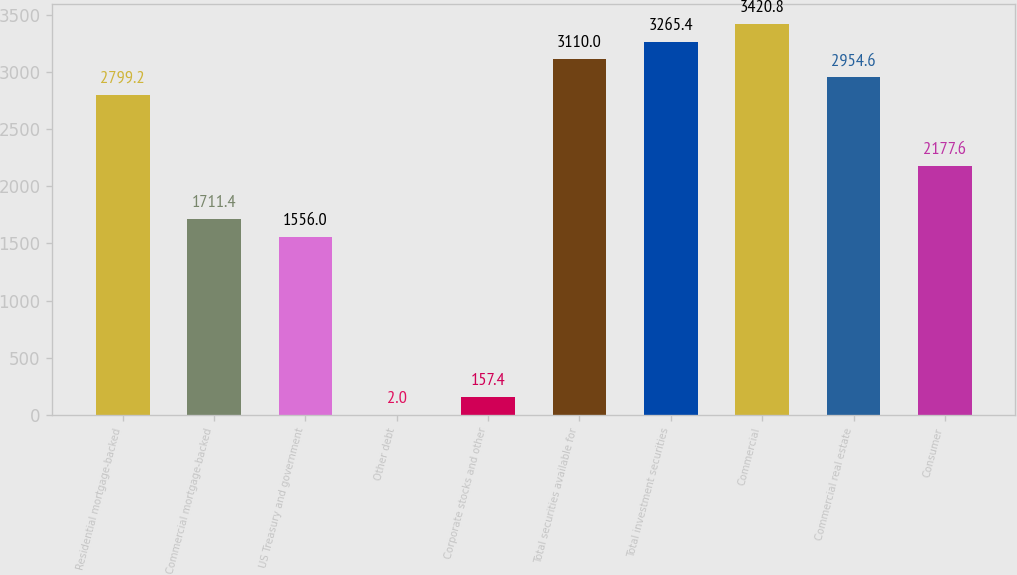<chart> <loc_0><loc_0><loc_500><loc_500><bar_chart><fcel>Residential mortgage-backed<fcel>Commercial mortgage-backed<fcel>US Treasury and government<fcel>Other debt<fcel>Corporate stocks and other<fcel>Total securities available for<fcel>Total investment securities<fcel>Commercial<fcel>Commercial real estate<fcel>Consumer<nl><fcel>2799.2<fcel>1711.4<fcel>1556<fcel>2<fcel>157.4<fcel>3110<fcel>3265.4<fcel>3420.8<fcel>2954.6<fcel>2177.6<nl></chart> 